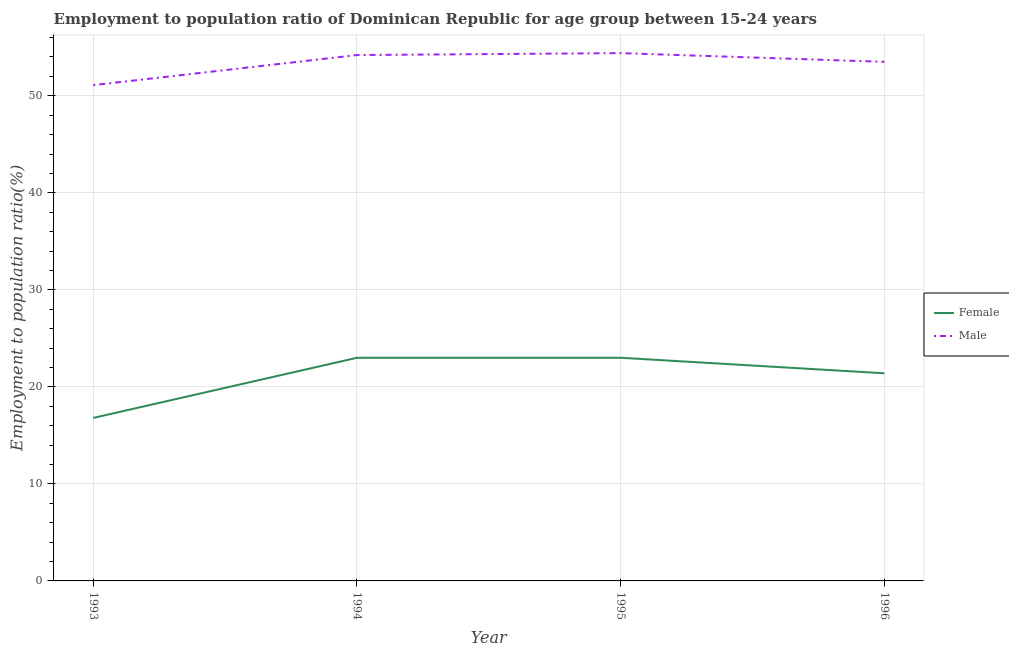Is the number of lines equal to the number of legend labels?
Offer a very short reply. Yes. What is the employment to population ratio(male) in 1996?
Provide a short and direct response. 53.5. Across all years, what is the maximum employment to population ratio(female)?
Provide a short and direct response. 23. Across all years, what is the minimum employment to population ratio(male)?
Your answer should be compact. 51.1. In which year was the employment to population ratio(male) maximum?
Make the answer very short. 1995. What is the total employment to population ratio(female) in the graph?
Ensure brevity in your answer.  84.2. What is the difference between the employment to population ratio(female) in 1994 and that in 1995?
Provide a short and direct response. 0. What is the difference between the employment to population ratio(male) in 1996 and the employment to population ratio(female) in 1995?
Give a very brief answer. 30.5. What is the average employment to population ratio(female) per year?
Your response must be concise. 21.05. In the year 1996, what is the difference between the employment to population ratio(male) and employment to population ratio(female)?
Provide a short and direct response. 32.1. In how many years, is the employment to population ratio(male) greater than 2 %?
Keep it short and to the point. 4. What is the ratio of the employment to population ratio(female) in 1993 to that in 1996?
Provide a succinct answer. 0.79. Is the employment to population ratio(male) in 1994 less than that in 1995?
Your answer should be compact. Yes. What is the difference between the highest and the lowest employment to population ratio(male)?
Provide a succinct answer. 3.3. In how many years, is the employment to population ratio(male) greater than the average employment to population ratio(male) taken over all years?
Ensure brevity in your answer.  3. Is the employment to population ratio(male) strictly less than the employment to population ratio(female) over the years?
Keep it short and to the point. No. How many lines are there?
Your response must be concise. 2. Are the values on the major ticks of Y-axis written in scientific E-notation?
Offer a terse response. No. Does the graph contain any zero values?
Provide a succinct answer. No. Does the graph contain grids?
Offer a very short reply. Yes. Where does the legend appear in the graph?
Provide a succinct answer. Center right. How many legend labels are there?
Offer a terse response. 2. How are the legend labels stacked?
Give a very brief answer. Vertical. What is the title of the graph?
Give a very brief answer. Employment to population ratio of Dominican Republic for age group between 15-24 years. Does "Male entrants" appear as one of the legend labels in the graph?
Make the answer very short. No. What is the label or title of the Y-axis?
Your response must be concise. Employment to population ratio(%). What is the Employment to population ratio(%) of Female in 1993?
Your response must be concise. 16.8. What is the Employment to population ratio(%) of Male in 1993?
Ensure brevity in your answer.  51.1. What is the Employment to population ratio(%) of Male in 1994?
Provide a succinct answer. 54.2. What is the Employment to population ratio(%) of Female in 1995?
Your answer should be compact. 23. What is the Employment to population ratio(%) in Male in 1995?
Give a very brief answer. 54.4. What is the Employment to population ratio(%) of Female in 1996?
Provide a short and direct response. 21.4. What is the Employment to population ratio(%) of Male in 1996?
Offer a very short reply. 53.5. Across all years, what is the maximum Employment to population ratio(%) of Female?
Provide a succinct answer. 23. Across all years, what is the maximum Employment to population ratio(%) in Male?
Ensure brevity in your answer.  54.4. Across all years, what is the minimum Employment to population ratio(%) of Female?
Offer a very short reply. 16.8. Across all years, what is the minimum Employment to population ratio(%) of Male?
Ensure brevity in your answer.  51.1. What is the total Employment to population ratio(%) in Female in the graph?
Your answer should be compact. 84.2. What is the total Employment to population ratio(%) in Male in the graph?
Your answer should be very brief. 213.2. What is the difference between the Employment to population ratio(%) of Male in 1993 and that in 1994?
Provide a succinct answer. -3.1. What is the difference between the Employment to population ratio(%) in Male in 1993 and that in 1995?
Your answer should be compact. -3.3. What is the difference between the Employment to population ratio(%) of Female in 1993 and that in 1996?
Keep it short and to the point. -4.6. What is the difference between the Employment to population ratio(%) of Female in 1994 and that in 1996?
Your answer should be compact. 1.6. What is the difference between the Employment to population ratio(%) of Male in 1995 and that in 1996?
Keep it short and to the point. 0.9. What is the difference between the Employment to population ratio(%) in Female in 1993 and the Employment to population ratio(%) in Male in 1994?
Your response must be concise. -37.4. What is the difference between the Employment to population ratio(%) in Female in 1993 and the Employment to population ratio(%) in Male in 1995?
Offer a terse response. -37.6. What is the difference between the Employment to population ratio(%) in Female in 1993 and the Employment to population ratio(%) in Male in 1996?
Make the answer very short. -36.7. What is the difference between the Employment to population ratio(%) of Female in 1994 and the Employment to population ratio(%) of Male in 1995?
Provide a short and direct response. -31.4. What is the difference between the Employment to population ratio(%) of Female in 1994 and the Employment to population ratio(%) of Male in 1996?
Keep it short and to the point. -30.5. What is the difference between the Employment to population ratio(%) of Female in 1995 and the Employment to population ratio(%) of Male in 1996?
Keep it short and to the point. -30.5. What is the average Employment to population ratio(%) of Female per year?
Your answer should be compact. 21.05. What is the average Employment to population ratio(%) of Male per year?
Keep it short and to the point. 53.3. In the year 1993, what is the difference between the Employment to population ratio(%) in Female and Employment to population ratio(%) in Male?
Ensure brevity in your answer.  -34.3. In the year 1994, what is the difference between the Employment to population ratio(%) of Female and Employment to population ratio(%) of Male?
Offer a terse response. -31.2. In the year 1995, what is the difference between the Employment to population ratio(%) in Female and Employment to population ratio(%) in Male?
Keep it short and to the point. -31.4. In the year 1996, what is the difference between the Employment to population ratio(%) in Female and Employment to population ratio(%) in Male?
Offer a terse response. -32.1. What is the ratio of the Employment to population ratio(%) of Female in 1993 to that in 1994?
Provide a short and direct response. 0.73. What is the ratio of the Employment to population ratio(%) of Male in 1993 to that in 1994?
Provide a succinct answer. 0.94. What is the ratio of the Employment to population ratio(%) in Female in 1993 to that in 1995?
Give a very brief answer. 0.73. What is the ratio of the Employment to population ratio(%) of Male in 1993 to that in 1995?
Provide a succinct answer. 0.94. What is the ratio of the Employment to population ratio(%) in Female in 1993 to that in 1996?
Your answer should be very brief. 0.79. What is the ratio of the Employment to population ratio(%) in Male in 1993 to that in 1996?
Make the answer very short. 0.96. What is the ratio of the Employment to population ratio(%) in Female in 1994 to that in 1996?
Your response must be concise. 1.07. What is the ratio of the Employment to population ratio(%) in Male in 1994 to that in 1996?
Your answer should be very brief. 1.01. What is the ratio of the Employment to population ratio(%) of Female in 1995 to that in 1996?
Your answer should be very brief. 1.07. What is the ratio of the Employment to population ratio(%) in Male in 1995 to that in 1996?
Keep it short and to the point. 1.02. 